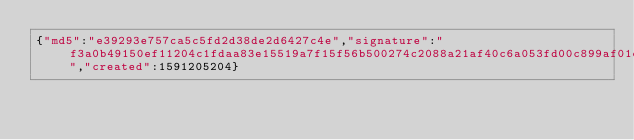<code> <loc_0><loc_0><loc_500><loc_500><_SML_>{"md5":"e39293e757ca5c5fd2d38de2d6427c4e","signature":"f3a0b49150ef11204c1fdaa83e15519a7f15f56b500274c2088a21af40c6a053fd00c899af01efdd427c83c15608f8e1d85bcc269d717b04ab60bcf7c40ec508","created":1591205204}</code> 